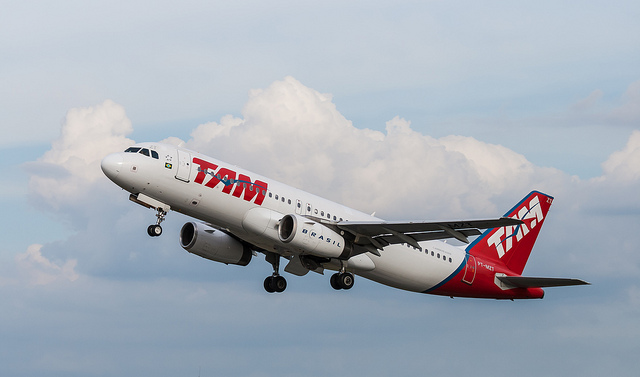<image>What country is written on the wing? I am not sure what country is written on the wing. It could be 'tam', 'usa', or 'brazil'. What country is written on the wing? I am not sure which country is written on the wing. It can be seen 'tam', 'usa' or 'brazil'. 